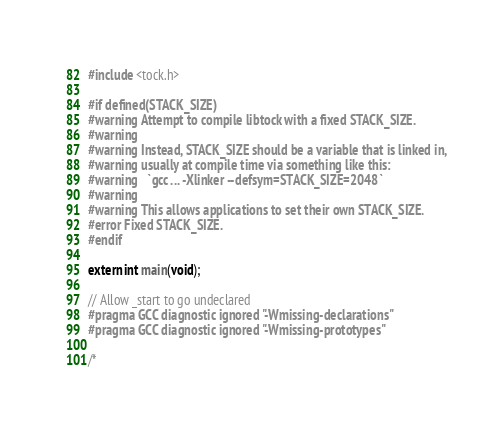Convert code to text. <code><loc_0><loc_0><loc_500><loc_500><_C_>#include <tock.h>

#if defined(STACK_SIZE)
#warning Attempt to compile libtock with a fixed STACK_SIZE.
#warning
#warning Instead, STACK_SIZE should be a variable that is linked in,
#warning usually at compile time via something like this:
#warning   `gcc ... -Xlinker --defsym=STACK_SIZE=2048`
#warning
#warning This allows applications to set their own STACK_SIZE.
#error Fixed STACK_SIZE.
#endif

extern int main(void);

// Allow _start to go undeclared
#pragma GCC diagnostic ignored "-Wmissing-declarations"
#pragma GCC diagnostic ignored "-Wmissing-prototypes"

/*</code> 